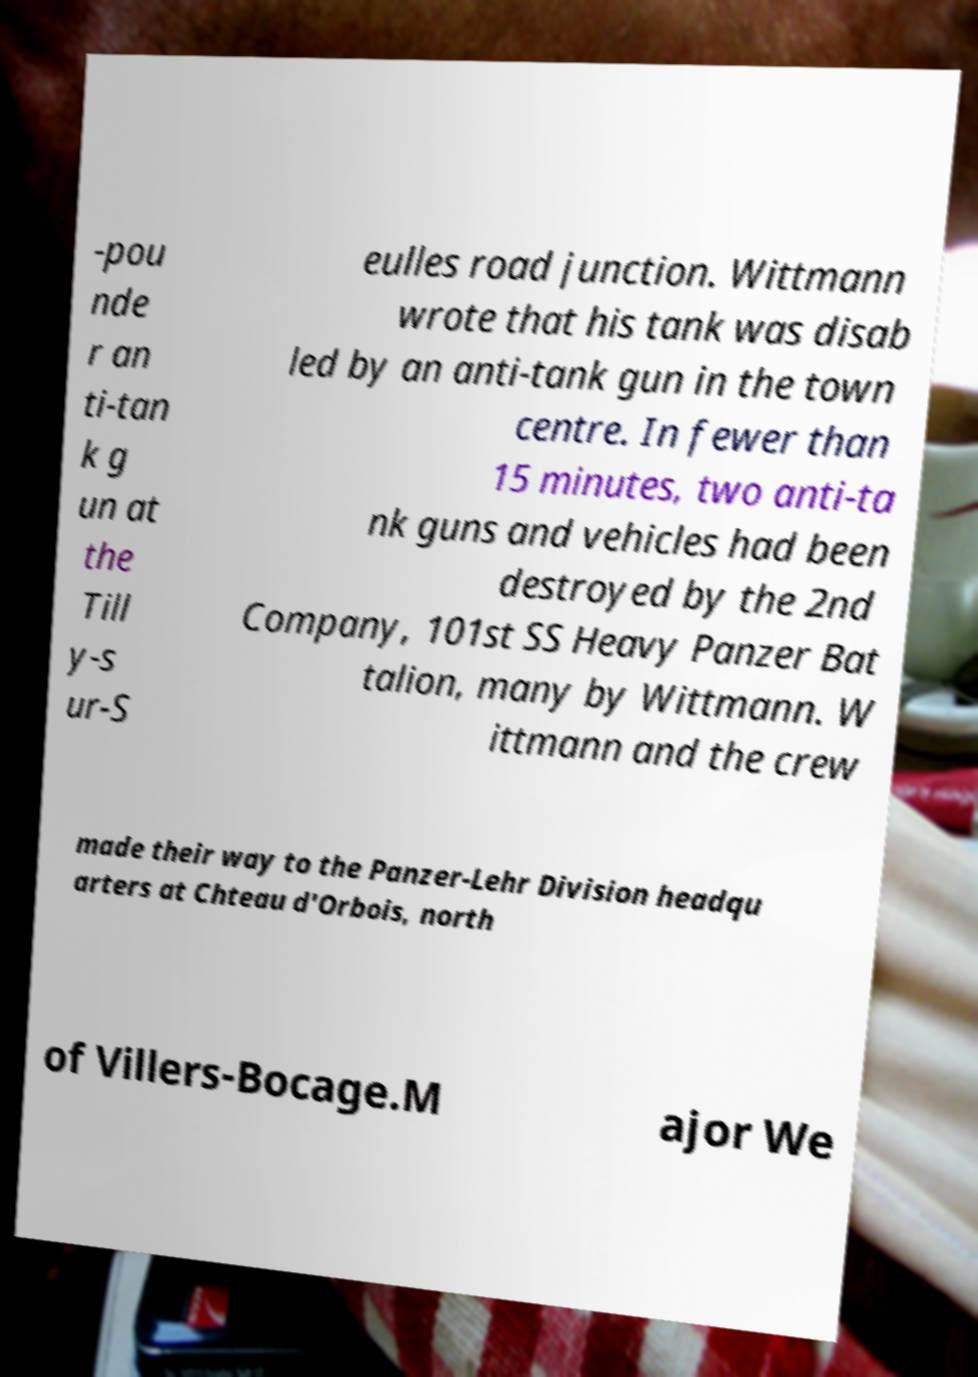Could you assist in decoding the text presented in this image and type it out clearly? -pou nde r an ti-tan k g un at the Till y-s ur-S eulles road junction. Wittmann wrote that his tank was disab led by an anti-tank gun in the town centre. In fewer than 15 minutes, two anti-ta nk guns and vehicles had been destroyed by the 2nd Company, 101st SS Heavy Panzer Bat talion, many by Wittmann. W ittmann and the crew made their way to the Panzer-Lehr Division headqu arters at Chteau d'Orbois, north of Villers-Bocage.M ajor We 